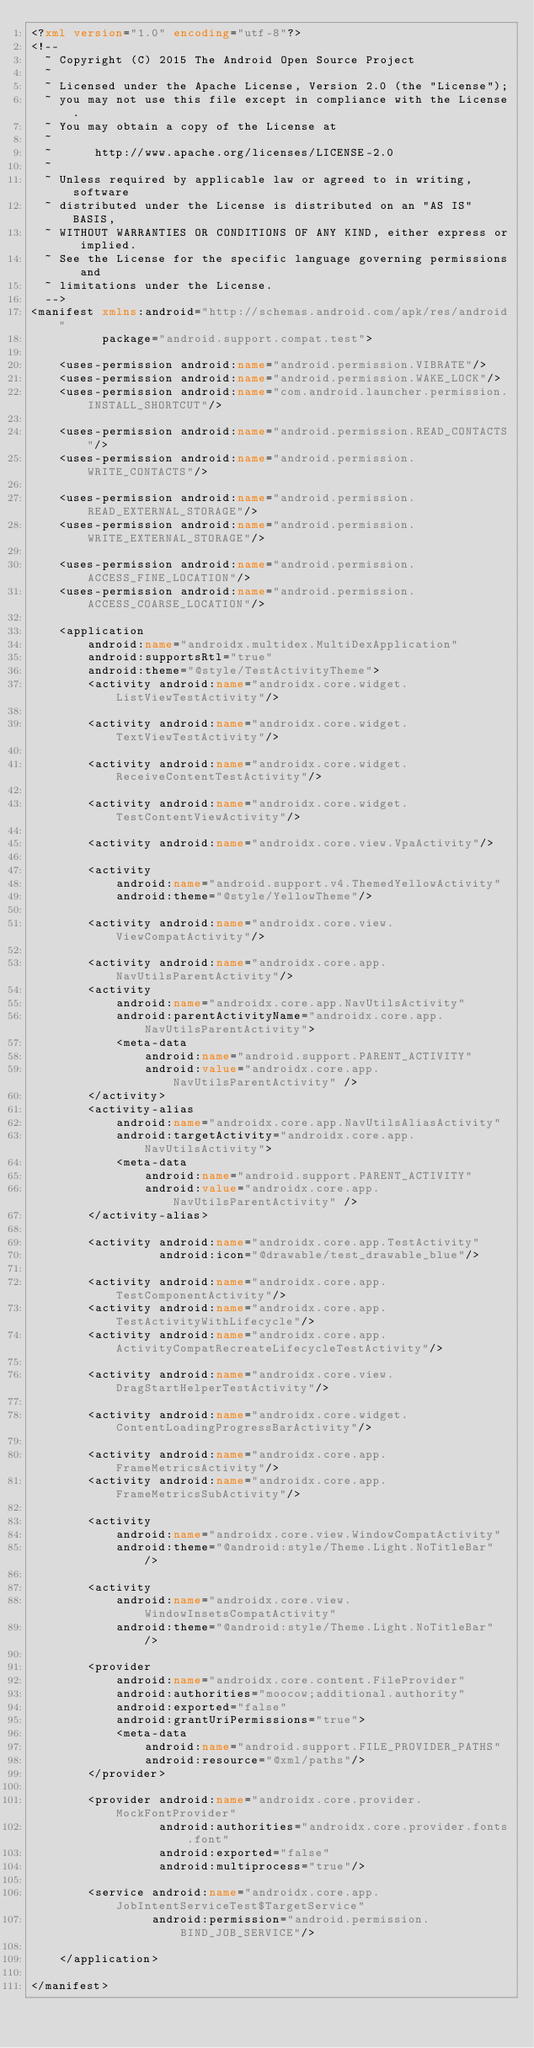<code> <loc_0><loc_0><loc_500><loc_500><_XML_><?xml version="1.0" encoding="utf-8"?>
<!--
  ~ Copyright (C) 2015 The Android Open Source Project
  ~
  ~ Licensed under the Apache License, Version 2.0 (the "License");
  ~ you may not use this file except in compliance with the License.
  ~ You may obtain a copy of the License at
  ~
  ~      http://www.apache.org/licenses/LICENSE-2.0
  ~
  ~ Unless required by applicable law or agreed to in writing, software
  ~ distributed under the License is distributed on an "AS IS" BASIS,
  ~ WITHOUT WARRANTIES OR CONDITIONS OF ANY KIND, either express or implied.
  ~ See the License for the specific language governing permissions and
  ~ limitations under the License.
  -->
<manifest xmlns:android="http://schemas.android.com/apk/res/android"
          package="android.support.compat.test">

    <uses-permission android:name="android.permission.VIBRATE"/>
    <uses-permission android:name="android.permission.WAKE_LOCK"/>
    <uses-permission android:name="com.android.launcher.permission.INSTALL_SHORTCUT"/>

    <uses-permission android:name="android.permission.READ_CONTACTS"/>
    <uses-permission android:name="android.permission.WRITE_CONTACTS"/>

    <uses-permission android:name="android.permission.READ_EXTERNAL_STORAGE"/>
    <uses-permission android:name="android.permission.WRITE_EXTERNAL_STORAGE"/>

    <uses-permission android:name="android.permission.ACCESS_FINE_LOCATION"/>
    <uses-permission android:name="android.permission.ACCESS_COARSE_LOCATION"/>

    <application
        android:name="androidx.multidex.MultiDexApplication"
        android:supportsRtl="true"
        android:theme="@style/TestActivityTheme">
        <activity android:name="androidx.core.widget.ListViewTestActivity"/>

        <activity android:name="androidx.core.widget.TextViewTestActivity"/>

        <activity android:name="androidx.core.widget.ReceiveContentTestActivity"/>

        <activity android:name="androidx.core.widget.TestContentViewActivity"/>

        <activity android:name="androidx.core.view.VpaActivity"/>

        <activity
            android:name="android.support.v4.ThemedYellowActivity"
            android:theme="@style/YellowTheme"/>

        <activity android:name="androidx.core.view.ViewCompatActivity"/>

        <activity android:name="androidx.core.app.NavUtilsParentActivity"/>
        <activity
            android:name="androidx.core.app.NavUtilsActivity"
            android:parentActivityName="androidx.core.app.NavUtilsParentActivity">
            <meta-data
                android:name="android.support.PARENT_ACTIVITY"
                android:value="androidx.core.app.NavUtilsParentActivity" />
        </activity>
        <activity-alias
            android:name="androidx.core.app.NavUtilsAliasActivity"
            android:targetActivity="androidx.core.app.NavUtilsActivity">
            <meta-data
                android:name="android.support.PARENT_ACTIVITY"
                android:value="androidx.core.app.NavUtilsParentActivity" />
        </activity-alias>

        <activity android:name="androidx.core.app.TestActivity"
                  android:icon="@drawable/test_drawable_blue"/>

        <activity android:name="androidx.core.app.TestComponentActivity"/>
        <activity android:name="androidx.core.app.TestActivityWithLifecycle"/>
        <activity android:name="androidx.core.app.ActivityCompatRecreateLifecycleTestActivity"/>

        <activity android:name="androidx.core.view.DragStartHelperTestActivity"/>

        <activity android:name="androidx.core.widget.ContentLoadingProgressBarActivity"/>

        <activity android:name="androidx.core.app.FrameMetricsActivity"/>
        <activity android:name="androidx.core.app.FrameMetricsSubActivity"/>

        <activity
            android:name="androidx.core.view.WindowCompatActivity"
            android:theme="@android:style/Theme.Light.NoTitleBar" />

        <activity
            android:name="androidx.core.view.WindowInsetsCompatActivity"
            android:theme="@android:style/Theme.Light.NoTitleBar" />

        <provider
            android:name="androidx.core.content.FileProvider"
            android:authorities="moocow;additional.authority"
            android:exported="false"
            android:grantUriPermissions="true">
            <meta-data
                android:name="android.support.FILE_PROVIDER_PATHS"
                android:resource="@xml/paths"/>
        </provider>

        <provider android:name="androidx.core.provider.MockFontProvider"
                  android:authorities="androidx.core.provider.fonts.font"
                  android:exported="false"
                  android:multiprocess="true"/>

        <service android:name="androidx.core.app.JobIntentServiceTest$TargetService"
                 android:permission="android.permission.BIND_JOB_SERVICE"/>

    </application>

</manifest>
</code> 